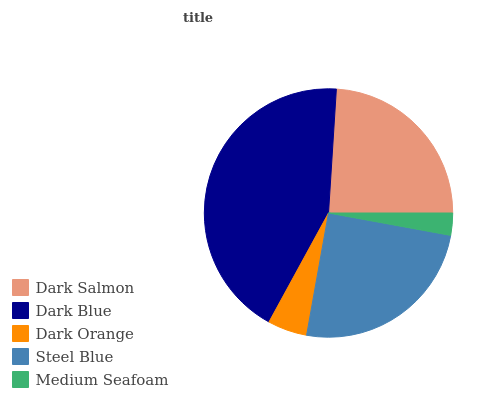Is Medium Seafoam the minimum?
Answer yes or no. Yes. Is Dark Blue the maximum?
Answer yes or no. Yes. Is Dark Orange the minimum?
Answer yes or no. No. Is Dark Orange the maximum?
Answer yes or no. No. Is Dark Blue greater than Dark Orange?
Answer yes or no. Yes. Is Dark Orange less than Dark Blue?
Answer yes or no. Yes. Is Dark Orange greater than Dark Blue?
Answer yes or no. No. Is Dark Blue less than Dark Orange?
Answer yes or no. No. Is Dark Salmon the high median?
Answer yes or no. Yes. Is Dark Salmon the low median?
Answer yes or no. Yes. Is Steel Blue the high median?
Answer yes or no. No. Is Steel Blue the low median?
Answer yes or no. No. 